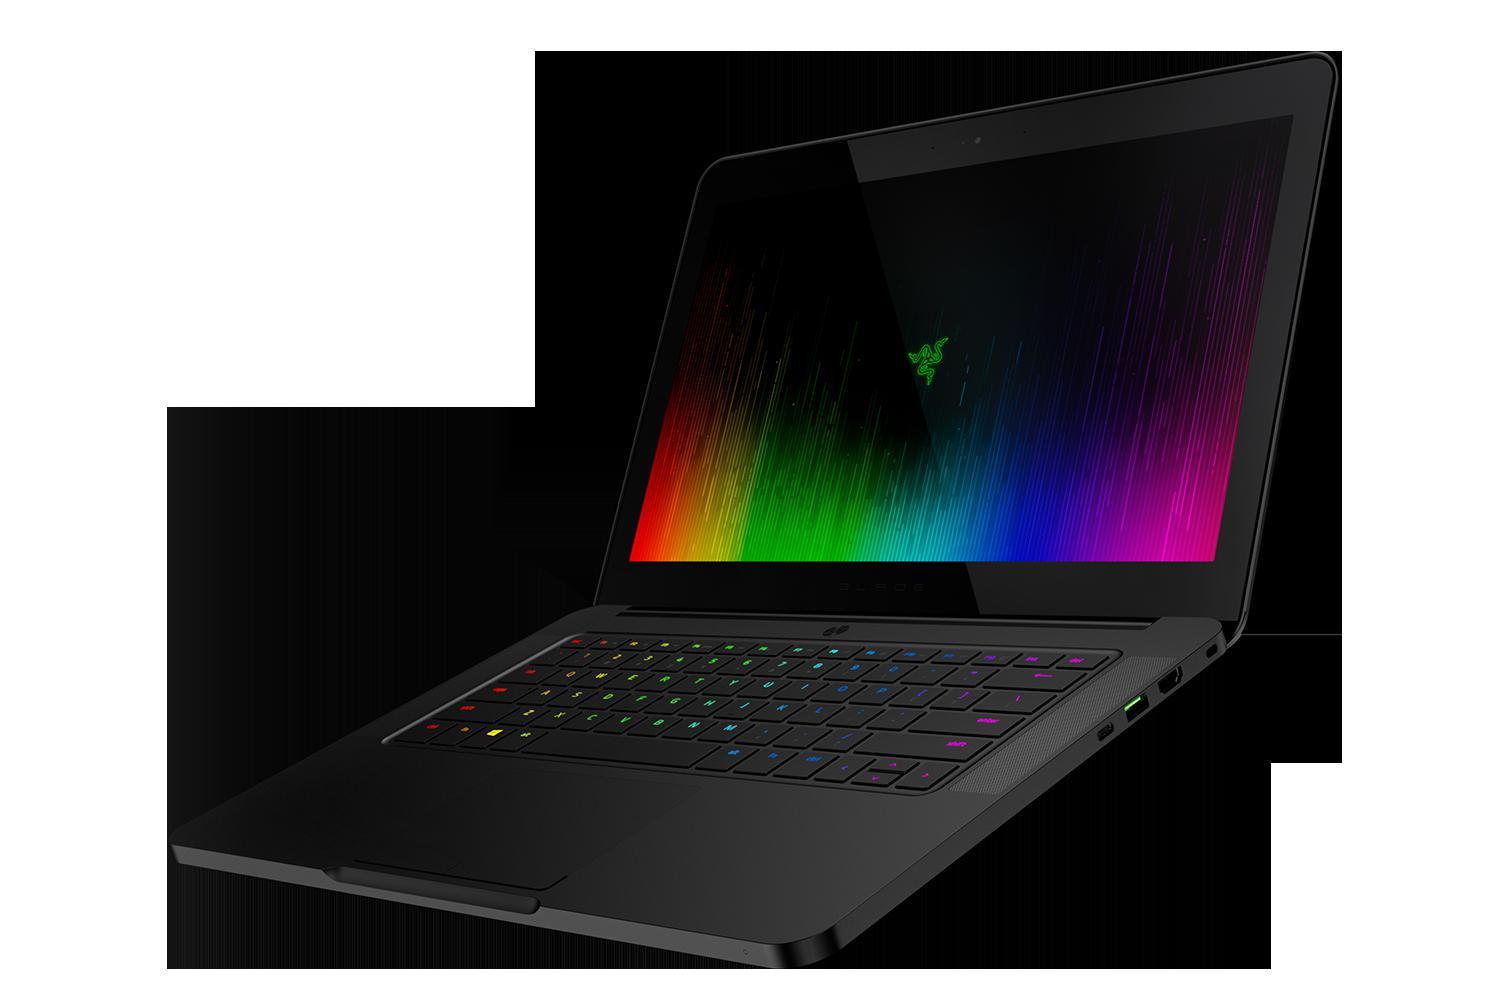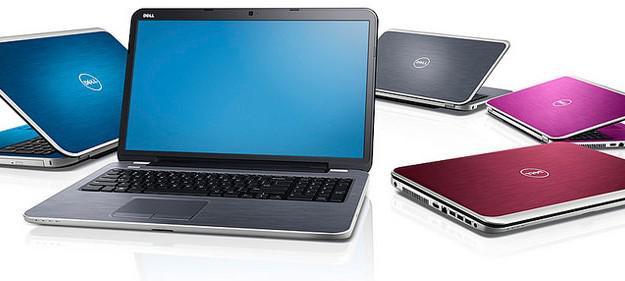The first image is the image on the left, the second image is the image on the right. Given the left and right images, does the statement "there are two laptops in the image, one is open and facing toward the camera, and one facing away" hold true? Answer yes or no. No. 